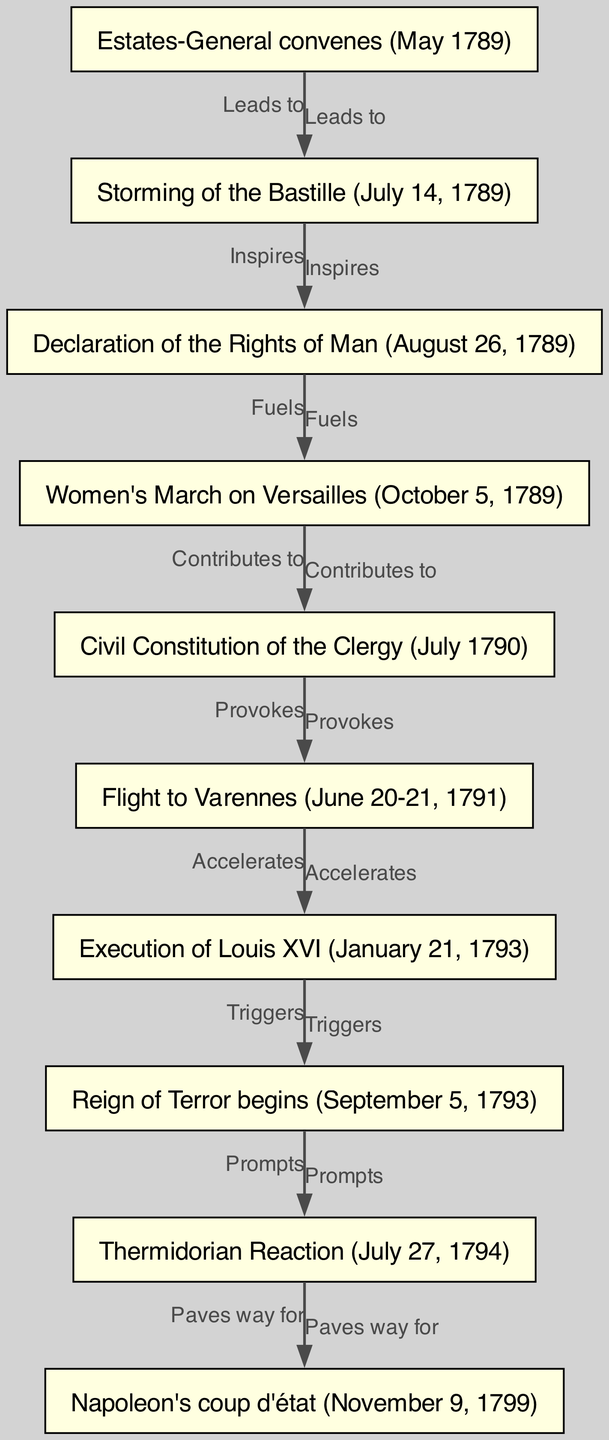What is the first event in the diagram? The first event listed in the diagram is the "Estates-General convenes (May 1789)," which is the starting point of the directed graph.
Answer: Estates-General convenes (May 1789) How many nodes are present in the diagram? By counting the unique events or nodes presented, there are a total of 10 nodes in the diagram that describe key events of the French Revolution.
Answer: 10 What event follows the Storming of the Bastille? The event that follows the "Storming of the Bastille (July 14, 1789)" is the "Declaration of the Rights of Man (August 26, 1789)", which is directly connected in the graph.
Answer: Declaration of the Rights of Man (August 26, 1789) What does the Execution of Louis XVI trigger? According to the diagram, the "Execution of Louis XVI (January 21, 1793)" triggers the "Reign of Terror begins (September 5, 1793)", indicating a cause-and-effect relationship.
Answer: Reign of Terror begins (September 5, 1793) Which event is described as leading to the Storming of the Bastille? The event that leads to the "Storming of the Bastille" is the "Estates-General convenes," indicating that the convening called for significant action and unrest.
Answer: Estates-General convenes (May 1789) How does the Women's March on Versailles contribute to the Civil Constitution of the Clergy? The "Women's March on Versailles (October 5, 1789)" contributes to the "Civil Constitution of the Clergy (July 1790)" as shown in the relationship labeled "Contributes to," suggesting a direct link in the progression of events.
Answer: Civil Constitution of the Clergy (July 1790) What is the relationship between the Thermidorian Reaction and Napoleon's coup d'état? The Thermidorian Reaction (July 27, 1794) paves the way for Napoleon's coup d'état (November 9, 1799), indicating that the outcomes of the former led to the conditions necessary for the latter event to occur.
Answer: Napoleon's coup d'état (November 9, 1799) 